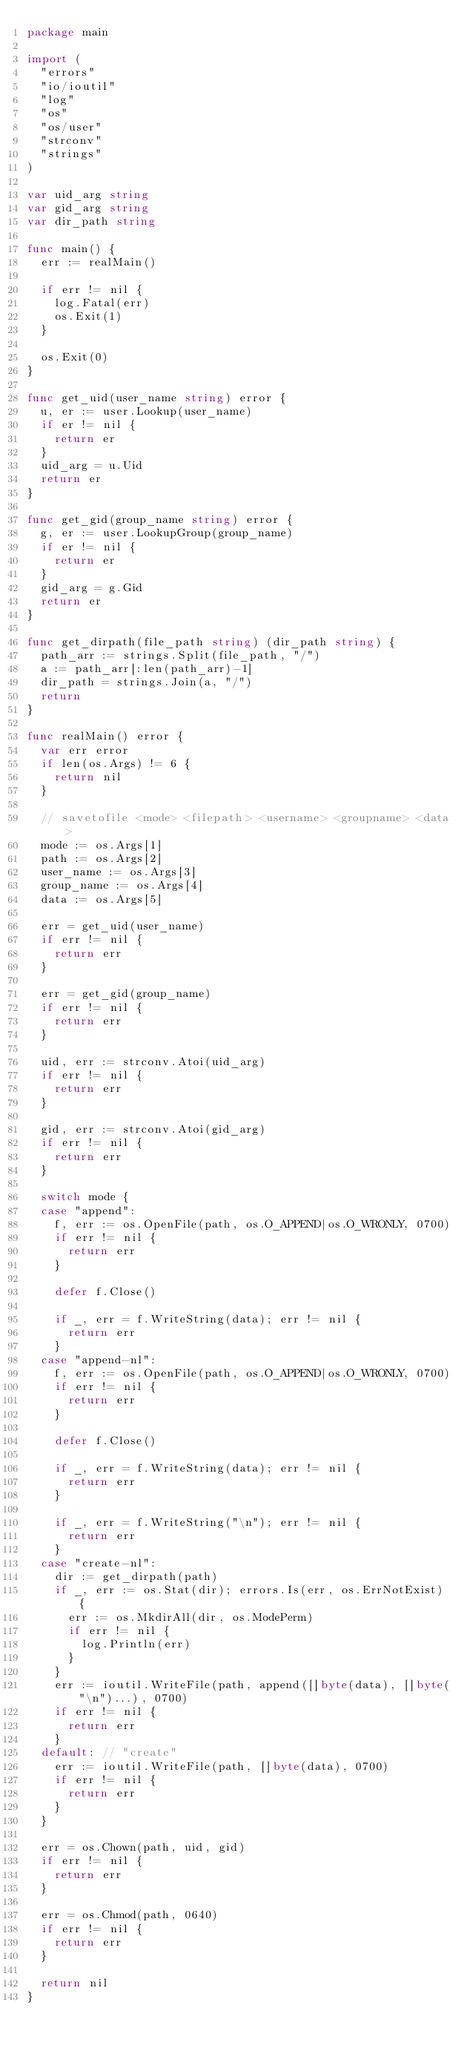<code> <loc_0><loc_0><loc_500><loc_500><_Go_>package main

import (
	"errors"
	"io/ioutil"
	"log"
	"os"
	"os/user"
	"strconv"
	"strings"
)

var uid_arg string
var gid_arg string
var dir_path string

func main() {
	err := realMain()

	if err != nil {
		log.Fatal(err)
		os.Exit(1)
	}

	os.Exit(0)
}

func get_uid(user_name string) error {
	u, er := user.Lookup(user_name)
	if er != nil {
		return er
	}
	uid_arg = u.Uid
	return er
}

func get_gid(group_name string) error {
	g, er := user.LookupGroup(group_name)
	if er != nil {
		return er
	}
	gid_arg = g.Gid
	return er
}

func get_dirpath(file_path string) (dir_path string) {
	path_arr := strings.Split(file_path, "/")
	a := path_arr[:len(path_arr)-1]
	dir_path = strings.Join(a, "/")
	return
}

func realMain() error {
	var err error
	if len(os.Args) != 6 {
		return nil
	}

	// savetofile <mode> <filepath> <username> <groupname> <data>
	mode := os.Args[1]
	path := os.Args[2]
	user_name := os.Args[3]
	group_name := os.Args[4]
	data := os.Args[5]

	err = get_uid(user_name)
	if err != nil {
		return err
	}

	err = get_gid(group_name)
	if err != nil {
		return err
	}

	uid, err := strconv.Atoi(uid_arg)
	if err != nil {
		return err
	}

	gid, err := strconv.Atoi(gid_arg)
	if err != nil {
		return err
	}

	switch mode {
	case "append":
		f, err := os.OpenFile(path, os.O_APPEND|os.O_WRONLY, 0700)
		if err != nil {
			return err
		}

		defer f.Close()

		if _, err = f.WriteString(data); err != nil {
			return err
		}
	case "append-nl":
		f, err := os.OpenFile(path, os.O_APPEND|os.O_WRONLY, 0700)
		if err != nil {
			return err
		}

		defer f.Close()

		if _, err = f.WriteString(data); err != nil {
			return err
		}

		if _, err = f.WriteString("\n"); err != nil {
			return err
		}
	case "create-nl":
		dir := get_dirpath(path)
		if _, err := os.Stat(dir); errors.Is(err, os.ErrNotExist) {
			err := os.MkdirAll(dir, os.ModePerm)
			if err != nil {
				log.Println(err)
			}
		}
		err := ioutil.WriteFile(path, append([]byte(data), []byte("\n")...), 0700)
		if err != nil {
			return err
		}
	default: // "create"
		err := ioutil.WriteFile(path, []byte(data), 0700)
		if err != nil {
			return err
		}
	}

	err = os.Chown(path, uid, gid)
	if err != nil {
		return err
	}

	err = os.Chmod(path, 0640)
	if err != nil {
		return err
	}

	return nil
}
</code> 